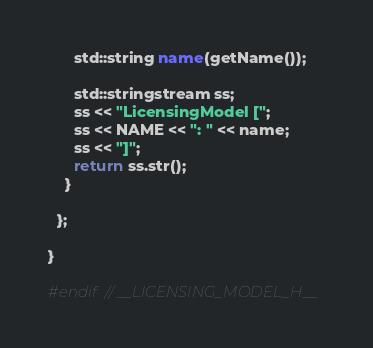<code> <loc_0><loc_0><loc_500><loc_500><_C_>      std::string name(getName());

      std::stringstream ss;
      ss << "LicensingModel [";
      ss << NAME << ": " << name;
      ss << "]";
      return ss.str();
    }

  };

}

#endif // __LICENSING_MODEL_H__
</code> 